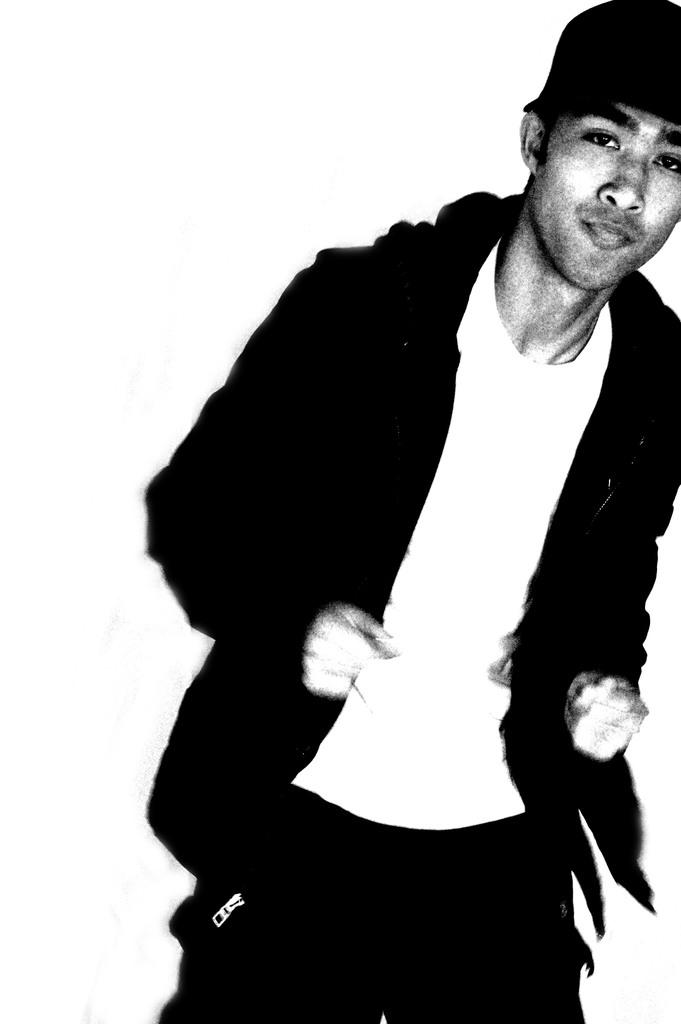What is the main subject of the image? There is a picture of a person standing in the image. What color is the background of the image? The background of the image is white. Where is the wheel located in the image? There is no wheel present in the image. What type of adjustment is being made to the person in the image? There is no adjustment being made to the person in the image; they are simply standing. 